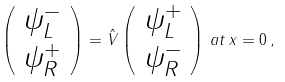Convert formula to latex. <formula><loc_0><loc_0><loc_500><loc_500>\left ( \begin{array} { c } \psi _ { L } ^ { - } \\ \psi _ { R } ^ { + } \\ \end{array} \right ) = \hat { V } \left ( \begin{array} { c } \psi _ { L } ^ { + } \\ \psi _ { R } ^ { - } \end{array} \right ) \, a t \, x = 0 \, ,</formula> 